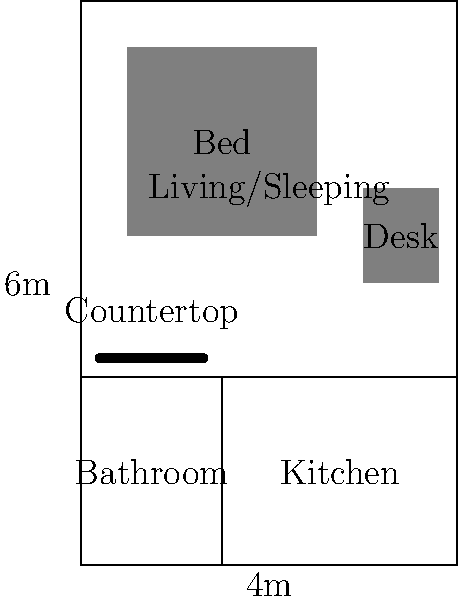As a civil engineering student, you're tasked with designing an efficient floor plan for a small studio apartment. The apartment measures 4m x 6m and must include a bathroom, kitchen area, and combined living/sleeping space. What is the minimum floor area (in square meters) required for the bathroom to meet basic accessibility standards, assuming a minimum width of 1.5m? To determine the minimum floor area for the bathroom while meeting basic accessibility standards, we need to follow these steps:

1. Identify the given constraints:
   - The apartment's total dimensions are 4m x 6m
   - The bathroom must have a minimum width of 1.5m

2. Consider accessibility standards:
   - A typical accessible bathroom requires a clear floor space of at least 1.5m x 1.5m for wheelchair maneuvering

3. Calculate the minimum bathroom dimensions:
   - Width: 1.5m (given minimum width)
   - Length: 1.5m (to meet the clear floor space requirement)

4. Calculate the minimum floor area:
   $$\text{Area} = \text{Width} \times \text{Length}$$
   $$\text{Area} = 1.5\text{m} \times 1.5\text{m} = 2.25\text{m}^2$$

5. Round up to the nearest quarter square meter for practicality:
   $$2.25\text{m}^2 \text{ rounded up} = 2.5\text{m}^2$$

Therefore, the minimum floor area required for the bathroom to meet basic accessibility standards is 2.5 square meters.
Answer: 2.5 m² 